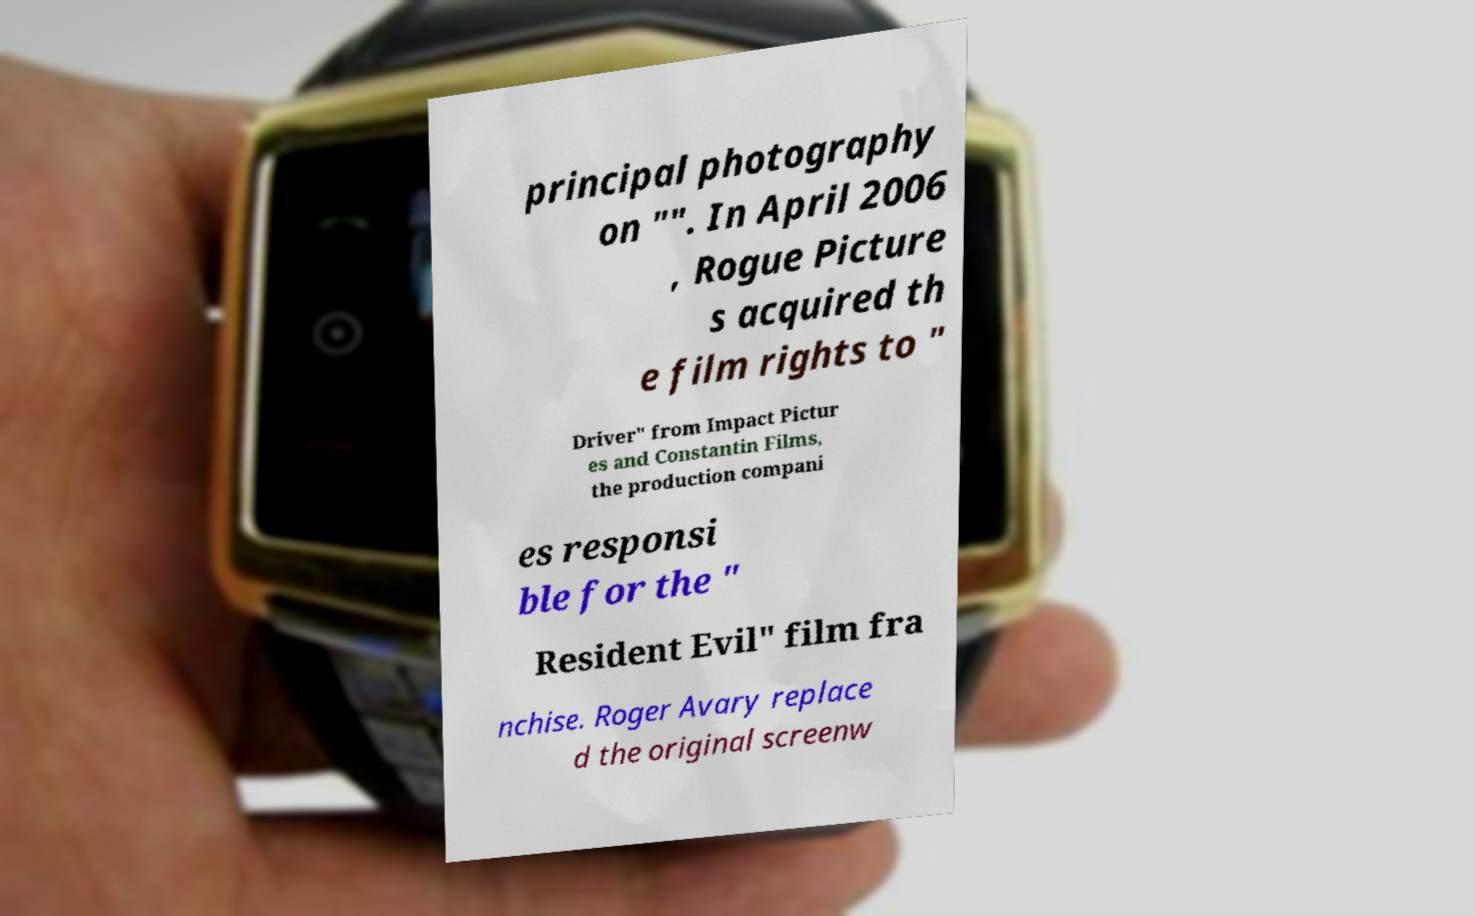Please identify and transcribe the text found in this image. principal photography on "". In April 2006 , Rogue Picture s acquired th e film rights to " Driver" from Impact Pictur es and Constantin Films, the production compani es responsi ble for the " Resident Evil" film fra nchise. Roger Avary replace d the original screenw 